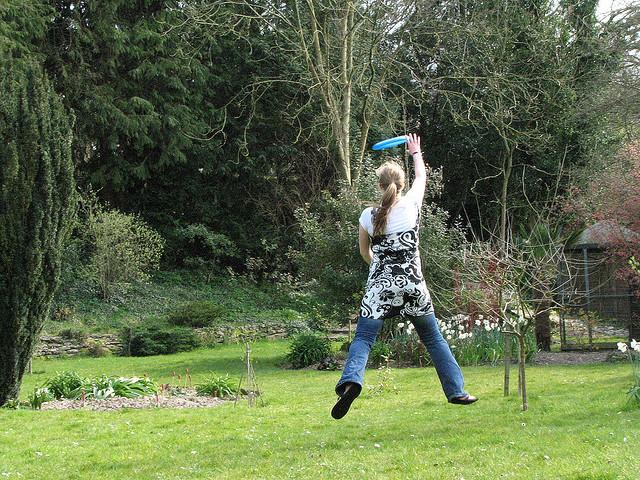Is she playing Frisbee at Burning Man?
Concise answer only. No. Is she catching or throwing the frisbee?
Answer briefly. Catching. Is someone else playing frisbee golf with the lady?
Short answer required. Yes. 